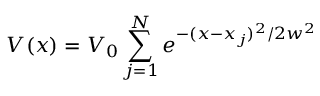Convert formula to latex. <formula><loc_0><loc_0><loc_500><loc_500>V ( x ) = V _ { 0 } \sum _ { j = 1 } ^ { N } { e ^ { - ( x - x _ { j } ) ^ { 2 } / 2 w ^ { 2 } } }</formula> 